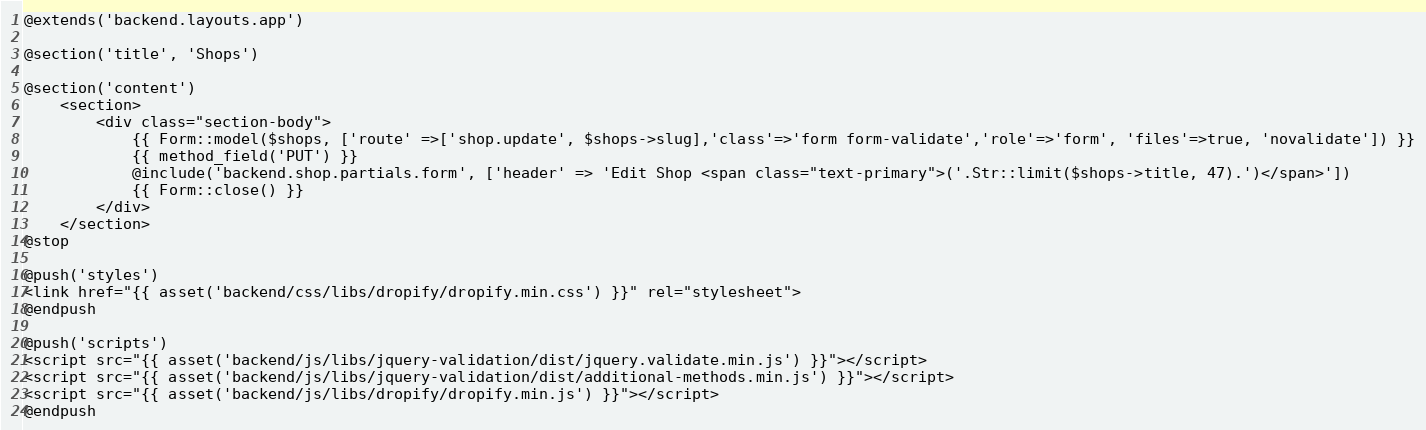<code> <loc_0><loc_0><loc_500><loc_500><_PHP_>@extends('backend.layouts.app')

@section('title', 'Shops')

@section('content')
    <section>
        <div class="section-body">
            {{ Form::model($shops, ['route' =>['shop.update', $shops->slug],'class'=>'form form-validate','role'=>'form', 'files'=>true, 'novalidate']) }}
            {{ method_field('PUT') }}
            @include('backend.shop.partials.form', ['header' => 'Edit Shop <span class="text-primary">('.Str::limit($shops->title, 47).')</span>'])
            {{ Form::close() }}
        </div>
    </section>
@stop

@push('styles')
<link href="{{ asset('backend/css/libs/dropify/dropify.min.css') }}" rel="stylesheet">
@endpush

@push('scripts')
<script src="{{ asset('backend/js/libs/jquery-validation/dist/jquery.validate.min.js') }}"></script>
<script src="{{ asset('backend/js/libs/jquery-validation/dist/additional-methods.min.js') }}"></script>
<script src="{{ asset('backend/js/libs/dropify/dropify.min.js') }}"></script>
@endpush
</code> 